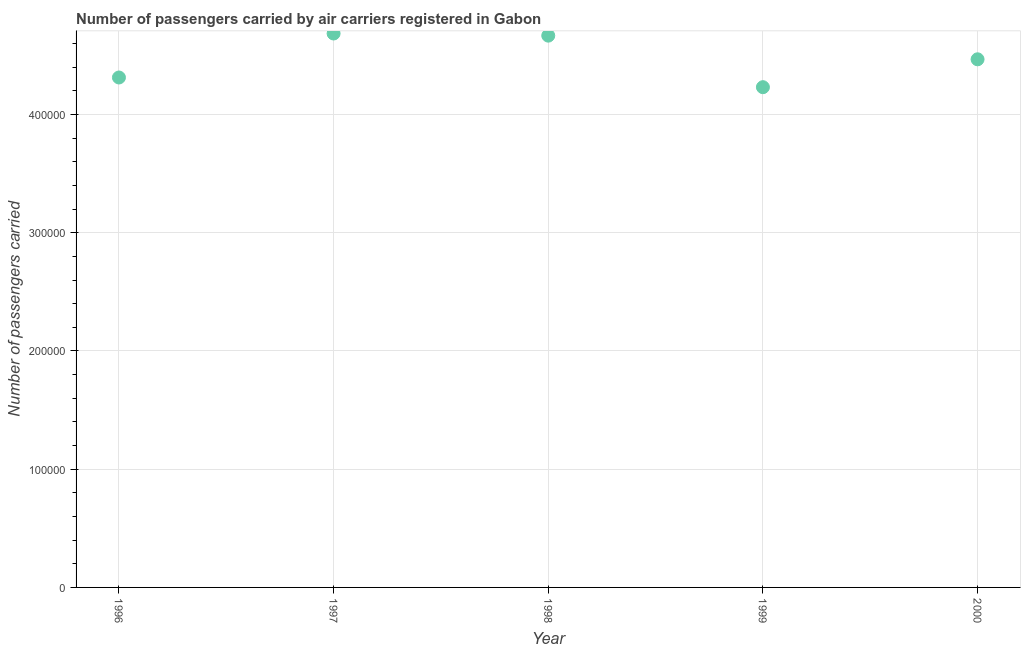What is the number of passengers carried in 1997?
Ensure brevity in your answer.  4.68e+05. Across all years, what is the maximum number of passengers carried?
Make the answer very short. 4.68e+05. Across all years, what is the minimum number of passengers carried?
Your answer should be compact. 4.23e+05. In which year was the number of passengers carried minimum?
Provide a short and direct response. 1999. What is the sum of the number of passengers carried?
Make the answer very short. 2.24e+06. What is the difference between the number of passengers carried in 1996 and 1998?
Give a very brief answer. -3.54e+04. What is the average number of passengers carried per year?
Make the answer very short. 4.47e+05. What is the median number of passengers carried?
Provide a succinct answer. 4.47e+05. In how many years, is the number of passengers carried greater than 440000 ?
Keep it short and to the point. 3. Do a majority of the years between 1996 and 1998 (inclusive) have number of passengers carried greater than 20000 ?
Make the answer very short. Yes. What is the ratio of the number of passengers carried in 1999 to that in 2000?
Provide a short and direct response. 0.95. Is the number of passengers carried in 1996 less than that in 1997?
Ensure brevity in your answer.  Yes. Is the difference between the number of passengers carried in 1999 and 2000 greater than the difference between any two years?
Your answer should be very brief. No. What is the difference between the highest and the second highest number of passengers carried?
Make the answer very short. 1800. Is the sum of the number of passengers carried in 1999 and 2000 greater than the maximum number of passengers carried across all years?
Your answer should be very brief. Yes. What is the difference between the highest and the lowest number of passengers carried?
Your response must be concise. 4.54e+04. How many dotlines are there?
Keep it short and to the point. 1. How many years are there in the graph?
Give a very brief answer. 5. What is the difference between two consecutive major ticks on the Y-axis?
Keep it short and to the point. 1.00e+05. Are the values on the major ticks of Y-axis written in scientific E-notation?
Make the answer very short. No. What is the title of the graph?
Ensure brevity in your answer.  Number of passengers carried by air carriers registered in Gabon. What is the label or title of the X-axis?
Offer a very short reply. Year. What is the label or title of the Y-axis?
Offer a very short reply. Number of passengers carried. What is the Number of passengers carried in 1996?
Your answer should be very brief. 4.31e+05. What is the Number of passengers carried in 1997?
Provide a short and direct response. 4.68e+05. What is the Number of passengers carried in 1998?
Your answer should be compact. 4.67e+05. What is the Number of passengers carried in 1999?
Provide a succinct answer. 4.23e+05. What is the Number of passengers carried in 2000?
Keep it short and to the point. 4.47e+05. What is the difference between the Number of passengers carried in 1996 and 1997?
Offer a terse response. -3.72e+04. What is the difference between the Number of passengers carried in 1996 and 1998?
Offer a terse response. -3.54e+04. What is the difference between the Number of passengers carried in 1996 and 1999?
Give a very brief answer. 8200. What is the difference between the Number of passengers carried in 1996 and 2000?
Provide a succinct answer. -1.54e+04. What is the difference between the Number of passengers carried in 1997 and 1998?
Give a very brief answer. 1800. What is the difference between the Number of passengers carried in 1997 and 1999?
Offer a very short reply. 4.54e+04. What is the difference between the Number of passengers carried in 1997 and 2000?
Ensure brevity in your answer.  2.18e+04. What is the difference between the Number of passengers carried in 1998 and 1999?
Offer a very short reply. 4.36e+04. What is the difference between the Number of passengers carried in 1998 and 2000?
Your answer should be very brief. 2.00e+04. What is the difference between the Number of passengers carried in 1999 and 2000?
Provide a short and direct response. -2.36e+04. What is the ratio of the Number of passengers carried in 1996 to that in 1997?
Give a very brief answer. 0.92. What is the ratio of the Number of passengers carried in 1996 to that in 1998?
Your answer should be very brief. 0.92. What is the ratio of the Number of passengers carried in 1996 to that in 1999?
Ensure brevity in your answer.  1.02. What is the ratio of the Number of passengers carried in 1996 to that in 2000?
Offer a terse response. 0.97. What is the ratio of the Number of passengers carried in 1997 to that in 1999?
Your answer should be very brief. 1.11. What is the ratio of the Number of passengers carried in 1997 to that in 2000?
Provide a short and direct response. 1.05. What is the ratio of the Number of passengers carried in 1998 to that in 1999?
Give a very brief answer. 1.1. What is the ratio of the Number of passengers carried in 1998 to that in 2000?
Give a very brief answer. 1.04. What is the ratio of the Number of passengers carried in 1999 to that in 2000?
Provide a succinct answer. 0.95. 